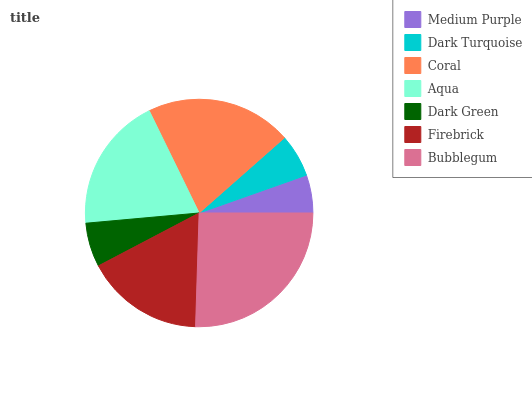Is Medium Purple the minimum?
Answer yes or no. Yes. Is Bubblegum the maximum?
Answer yes or no. Yes. Is Dark Turquoise the minimum?
Answer yes or no. No. Is Dark Turquoise the maximum?
Answer yes or no. No. Is Dark Turquoise greater than Medium Purple?
Answer yes or no. Yes. Is Medium Purple less than Dark Turquoise?
Answer yes or no. Yes. Is Medium Purple greater than Dark Turquoise?
Answer yes or no. No. Is Dark Turquoise less than Medium Purple?
Answer yes or no. No. Is Firebrick the high median?
Answer yes or no. Yes. Is Firebrick the low median?
Answer yes or no. Yes. Is Dark Green the high median?
Answer yes or no. No. Is Medium Purple the low median?
Answer yes or no. No. 